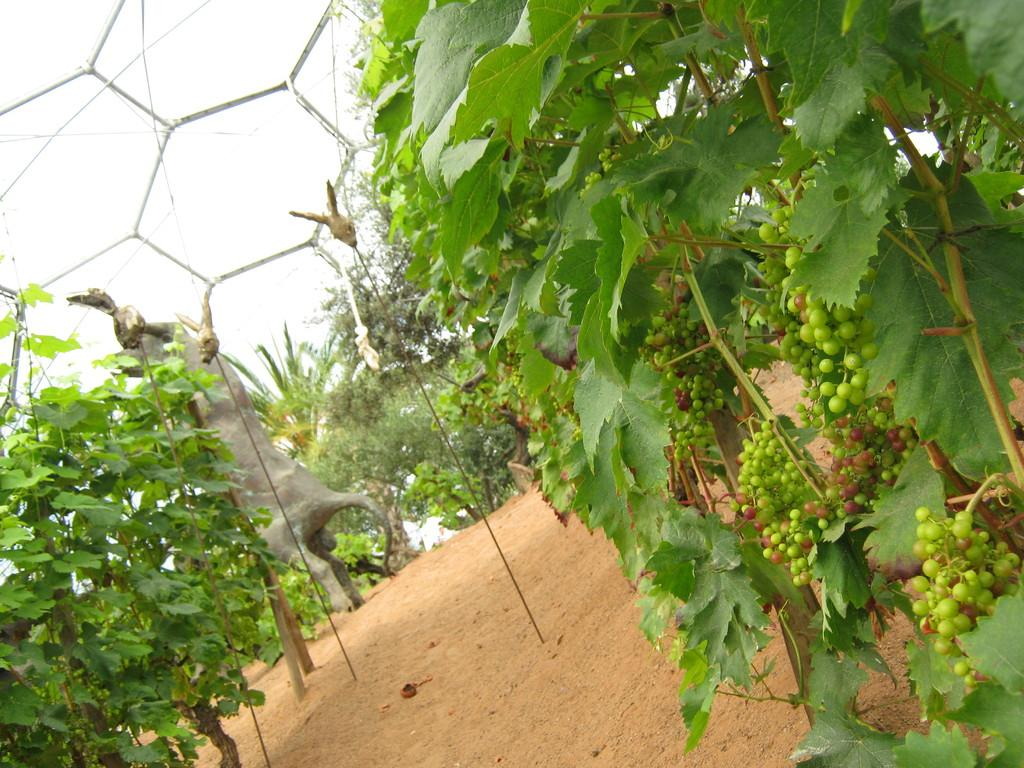What is the main subject in the image? There is a statue in the image. What type of natural elements can be seen in the image? There are trees in the image. What else is present on the ground in the image? There are other objects on the ground in the image. What can be seen in the distance in the image? The sky is visible in the background of the image, and there is an unspecified object in the background. Can you see any boots on the statue in the image? There are no boots visible on the statue in the image. Are there any trails visible in the image? There are no trails visible in the image; it features a statue, trees, and other objects on the ground. 